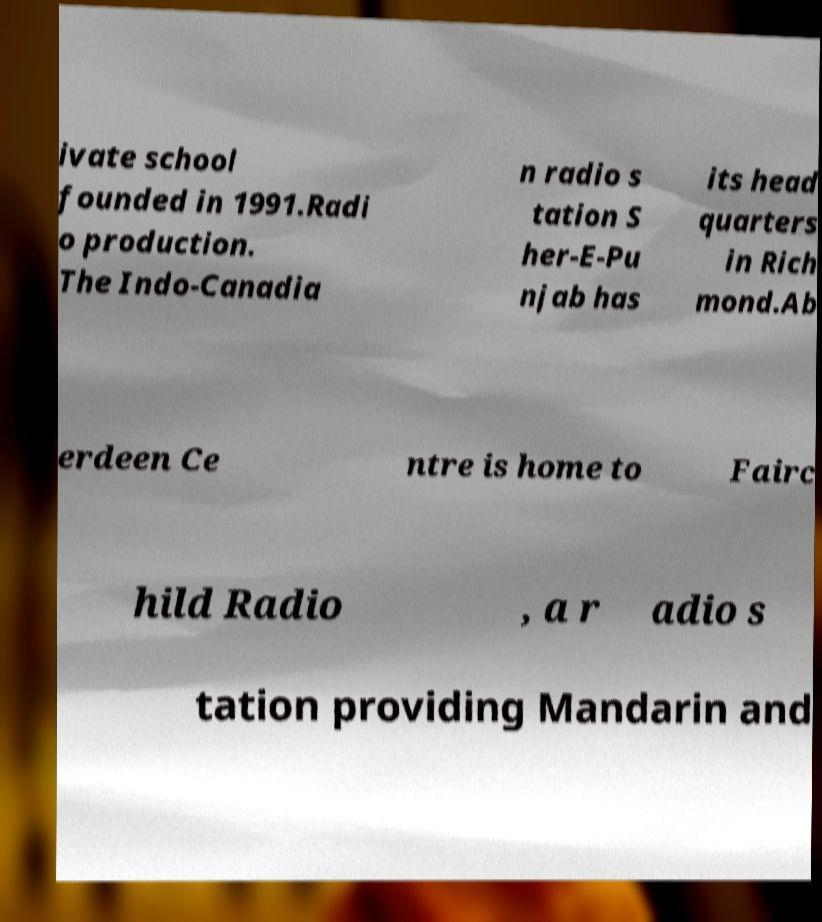Can you read and provide the text displayed in the image?This photo seems to have some interesting text. Can you extract and type it out for me? ivate school founded in 1991.Radi o production. The Indo-Canadia n radio s tation S her-E-Pu njab has its head quarters in Rich mond.Ab erdeen Ce ntre is home to Fairc hild Radio , a r adio s tation providing Mandarin and 